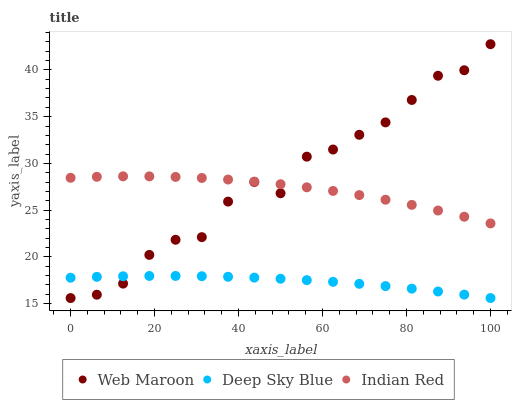Does Deep Sky Blue have the minimum area under the curve?
Answer yes or no. Yes. Does Web Maroon have the maximum area under the curve?
Answer yes or no. Yes. Does Indian Red have the minimum area under the curve?
Answer yes or no. No. Does Indian Red have the maximum area under the curve?
Answer yes or no. No. Is Deep Sky Blue the smoothest?
Answer yes or no. Yes. Is Web Maroon the roughest?
Answer yes or no. Yes. Is Indian Red the smoothest?
Answer yes or no. No. Is Indian Red the roughest?
Answer yes or no. No. Does Web Maroon have the lowest value?
Answer yes or no. Yes. Does Deep Sky Blue have the lowest value?
Answer yes or no. No. Does Web Maroon have the highest value?
Answer yes or no. Yes. Does Indian Red have the highest value?
Answer yes or no. No. Is Deep Sky Blue less than Indian Red?
Answer yes or no. Yes. Is Indian Red greater than Deep Sky Blue?
Answer yes or no. Yes. Does Web Maroon intersect Indian Red?
Answer yes or no. Yes. Is Web Maroon less than Indian Red?
Answer yes or no. No. Is Web Maroon greater than Indian Red?
Answer yes or no. No. Does Deep Sky Blue intersect Indian Red?
Answer yes or no. No. 